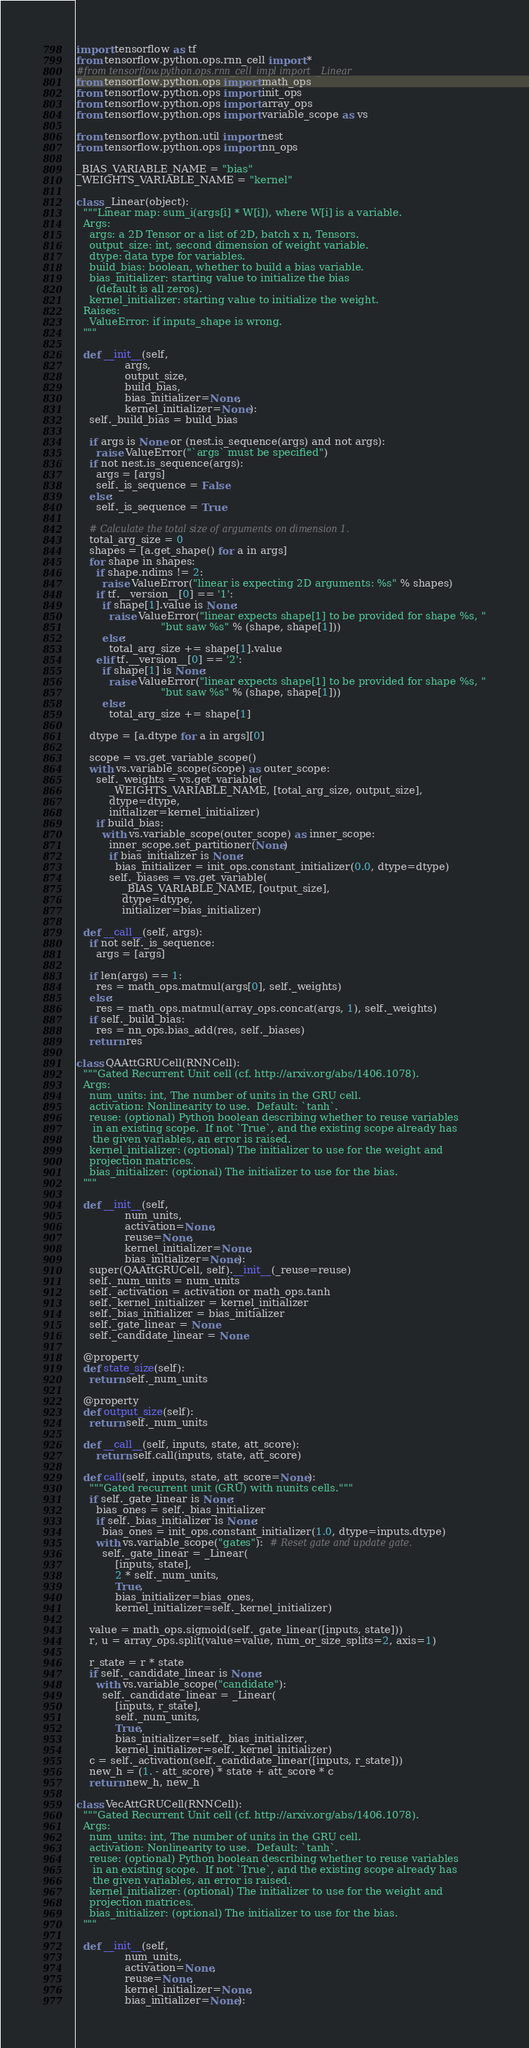<code> <loc_0><loc_0><loc_500><loc_500><_Python_>import tensorflow as tf
from tensorflow.python.ops.rnn_cell import *
#from tensorflow.python.ops.rnn_cell_impl import  _Linear
from tensorflow.python.ops import math_ops
from tensorflow.python.ops import init_ops
from tensorflow.python.ops import array_ops
from tensorflow.python.ops import variable_scope as vs

from tensorflow.python.util import nest
from tensorflow.python.ops import nn_ops

_BIAS_VARIABLE_NAME = "bias"
_WEIGHTS_VARIABLE_NAME = "kernel"

class _Linear(object):
  """Linear map: sum_i(args[i] * W[i]), where W[i] is a variable.
  Args:
    args: a 2D Tensor or a list of 2D, batch x n, Tensors.
    output_size: int, second dimension of weight variable.
    dtype: data type for variables.
    build_bias: boolean, whether to build a bias variable.
    bias_initializer: starting value to initialize the bias
      (default is all zeros).
    kernel_initializer: starting value to initialize the weight.
  Raises:
    ValueError: if inputs_shape is wrong.
  """

  def __init__(self,
               args,
               output_size,
               build_bias,
               bias_initializer=None,
               kernel_initializer=None):
    self._build_bias = build_bias

    if args is None or (nest.is_sequence(args) and not args):
      raise ValueError("`args` must be specified")
    if not nest.is_sequence(args):
      args = [args]
      self._is_sequence = False
    else:
      self._is_sequence = True

    # Calculate the total size of arguments on dimension 1.
    total_arg_size = 0
    shapes = [a.get_shape() for a in args]
    for shape in shapes:
      if shape.ndims != 2:
        raise ValueError("linear is expecting 2D arguments: %s" % shapes)
      if tf.__version__[0] == '1':
        if shape[1].value is None:
          raise ValueError("linear expects shape[1] to be provided for shape %s, "
                          "but saw %s" % (shape, shape[1]))
        else:
          total_arg_size += shape[1].value
      elif tf.__version__[0] == '2':
        if shape[1] is None:
          raise ValueError("linear expects shape[1] to be provided for shape %s, "
                          "but saw %s" % (shape, shape[1]))
        else:
          total_arg_size += shape[1]

    dtype = [a.dtype for a in args][0]

    scope = vs.get_variable_scope()
    with vs.variable_scope(scope) as outer_scope:
      self._weights = vs.get_variable(
          _WEIGHTS_VARIABLE_NAME, [total_arg_size, output_size],
          dtype=dtype,
          initializer=kernel_initializer)
      if build_bias:
        with vs.variable_scope(outer_scope) as inner_scope:
          inner_scope.set_partitioner(None)
          if bias_initializer is None:
            bias_initializer = init_ops.constant_initializer(0.0, dtype=dtype)
          self._biases = vs.get_variable(
              _BIAS_VARIABLE_NAME, [output_size],
              dtype=dtype,
              initializer=bias_initializer)

  def __call__(self, args):
    if not self._is_sequence:
      args = [args]

    if len(args) == 1:
      res = math_ops.matmul(args[0], self._weights)
    else:
      res = math_ops.matmul(array_ops.concat(args, 1), self._weights)
    if self._build_bias:
      res = nn_ops.bias_add(res, self._biases)
    return res

class QAAttGRUCell(RNNCell):
  """Gated Recurrent Unit cell (cf. http://arxiv.org/abs/1406.1078).
  Args:
    num_units: int, The number of units in the GRU cell.
    activation: Nonlinearity to use.  Default: `tanh`.
    reuse: (optional) Python boolean describing whether to reuse variables
     in an existing scope.  If not `True`, and the existing scope already has
     the given variables, an error is raised.
    kernel_initializer: (optional) The initializer to use for the weight and
    projection matrices.
    bias_initializer: (optional) The initializer to use for the bias.
  """

  def __init__(self,
               num_units,
               activation=None,
               reuse=None,
               kernel_initializer=None,
               bias_initializer=None):
    super(QAAttGRUCell, self).__init__(_reuse=reuse)
    self._num_units = num_units
    self._activation = activation or math_ops.tanh
    self._kernel_initializer = kernel_initializer
    self._bias_initializer = bias_initializer
    self._gate_linear = None
    self._candidate_linear = None

  @property
  def state_size(self):
    return self._num_units

  @property
  def output_size(self):
    return self._num_units

  def __call__(self, inputs, state, att_score):
      return self.call(inputs, state, att_score)

  def call(self, inputs, state, att_score=None):
    """Gated recurrent unit (GRU) with nunits cells."""
    if self._gate_linear is None:
      bias_ones = self._bias_initializer
      if self._bias_initializer is None:
        bias_ones = init_ops.constant_initializer(1.0, dtype=inputs.dtype)
      with vs.variable_scope("gates"):  # Reset gate and update gate.
        self._gate_linear = _Linear(
            [inputs, state],
            2 * self._num_units,
            True,
            bias_initializer=bias_ones,
            kernel_initializer=self._kernel_initializer)

    value = math_ops.sigmoid(self._gate_linear([inputs, state]))
    r, u = array_ops.split(value=value, num_or_size_splits=2, axis=1)

    r_state = r * state
    if self._candidate_linear is None:
      with vs.variable_scope("candidate"):
        self._candidate_linear = _Linear(
            [inputs, r_state],
            self._num_units,
            True,
            bias_initializer=self._bias_initializer,
            kernel_initializer=self._kernel_initializer)
    c = self._activation(self._candidate_linear([inputs, r_state]))
    new_h = (1. - att_score) * state + att_score * c
    return new_h, new_h

class VecAttGRUCell(RNNCell):
  """Gated Recurrent Unit cell (cf. http://arxiv.org/abs/1406.1078).
  Args:
    num_units: int, The number of units in the GRU cell.
    activation: Nonlinearity to use.  Default: `tanh`.
    reuse: (optional) Python boolean describing whether to reuse variables
     in an existing scope.  If not `True`, and the existing scope already has
     the given variables, an error is raised.
    kernel_initializer: (optional) The initializer to use for the weight and
    projection matrices.
    bias_initializer: (optional) The initializer to use for the bias.
  """

  def __init__(self,
               num_units,
               activation=None,
               reuse=None,
               kernel_initializer=None,
               bias_initializer=None):</code> 